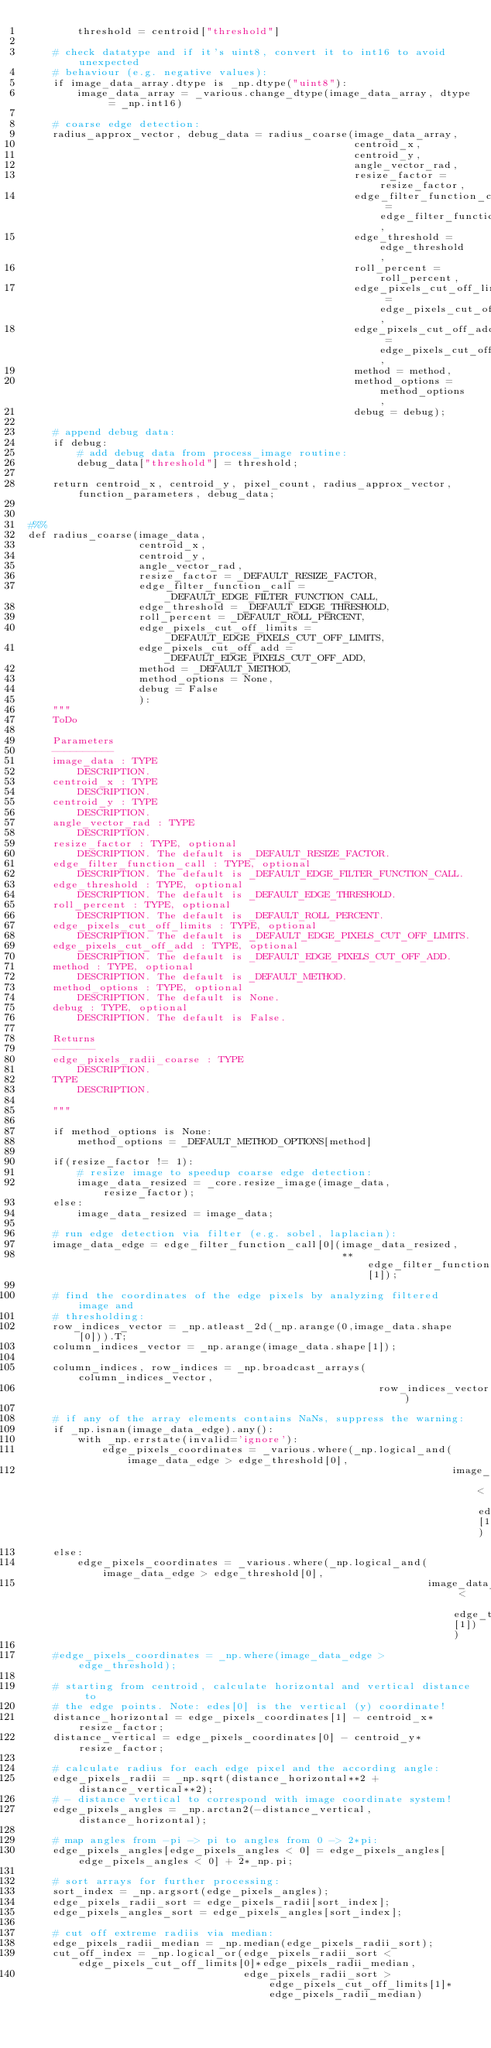<code> <loc_0><loc_0><loc_500><loc_500><_Python_>        threshold = centroid["threshold"]
    
    # check datatype and if it's uint8, convert it to int16 to avoid unexpected
    # behaviour (e.g. negative values):
    if image_data_array.dtype is _np.dtype("uint8"):   
        image_data_array = _various.change_dtype(image_data_array, dtype = _np.int16)
    
    # coarse edge detection:
    radius_approx_vector, debug_data = radius_coarse(image_data_array,
                                                     centroid_x,
                                                     centroid_y, 
                                                     angle_vector_rad,
                                                     resize_factor = resize_factor,
                                                     edge_filter_function_call = edge_filter_function_call,
                                                     edge_threshold = edge_threshold,
                                                     roll_percent = roll_percent,
                                                     edge_pixels_cut_off_limits = edge_pixels_cut_off_limits,
                                                     edge_pixels_cut_off_add = edge_pixels_cut_off_add,
                                                     method = method,
                                                     method_options = method_options,
                                                     debug = debug);
    
    # append debug data:
    if debug:
        # add debug data from process_image routine:
        debug_data["threshold"] = threshold;
    
    return centroid_x, centroid_y, pixel_count, radius_approx_vector, function_parameters, debug_data;


#%%
def radius_coarse(image_data,
                  centroid_x,
                  centroid_y,
                  angle_vector_rad, 
                  resize_factor = _DEFAULT_RESIZE_FACTOR,
                  edge_filter_function_call = _DEFAULT_EDGE_FILTER_FUNCTION_CALL,
                  edge_threshold = _DEFAULT_EDGE_THRESHOLD,
                  roll_percent = _DEFAULT_ROLL_PERCENT,
                  edge_pixels_cut_off_limits = _DEFAULT_EDGE_PIXELS_CUT_OFF_LIMITS,
                  edge_pixels_cut_off_add = _DEFAULT_EDGE_PIXELS_CUT_OFF_ADD,
                  method = _DEFAULT_METHOD,
                  method_options = None,
                  debug = False
                  ):
    """
    ToDo

    Parameters
    ----------
    image_data : TYPE
        DESCRIPTION.
    centroid_x : TYPE
        DESCRIPTION.
    centroid_y : TYPE
        DESCRIPTION.
    angle_vector_rad : TYPE
        DESCRIPTION.
    resize_factor : TYPE, optional
        DESCRIPTION. The default is _DEFAULT_RESIZE_FACTOR.
    edge_filter_function_call : TYPE, optional
        DESCRIPTION. The default is _DEFAULT_EDGE_FILTER_FUNCTION_CALL.
    edge_threshold : TYPE, optional
        DESCRIPTION. The default is _DEFAULT_EDGE_THRESHOLD.
    roll_percent : TYPE, optional
        DESCRIPTION. The default is _DEFAULT_ROLL_PERCENT.
    edge_pixels_cut_off_limits : TYPE, optional
        DESCRIPTION. The default is _DEFAULT_EDGE_PIXELS_CUT_OFF_LIMITS.
    edge_pixels_cut_off_add : TYPE, optional
        DESCRIPTION. The default is _DEFAULT_EDGE_PIXELS_CUT_OFF_ADD.
    method : TYPE, optional
        DESCRIPTION. The default is _DEFAULT_METHOD.
    method_options : TYPE, optional
        DESCRIPTION. The default is None.
    debug : TYPE, optional
        DESCRIPTION. The default is False.

    Returns
    -------
    edge_pixels_radii_coarse : TYPE
        DESCRIPTION.
    TYPE
        DESCRIPTION.

    """
    
    if method_options is None:
        method_options = _DEFAULT_METHOD_OPTIONS[method]
    
    if(resize_factor != 1):
        # resize image to speedup coarse edge detection:
        image_data_resized = _core.resize_image(image_data, resize_factor);
    else:
        image_data_resized = image_data;
    
    # run edge detection via filter (e.g. sobel, laplacian):
    image_data_edge = edge_filter_function_call[0](image_data_resized,
                                                   **edge_filter_function_call[1]);
    
    # find the coordinates of the edge pixels by analyzing filtered image and 
    # thresholding:
    row_indices_vector = _np.atleast_2d(_np.arange(0,image_data.shape[0])).T;
    column_indices_vector = _np.arange(image_data.shape[1]);
    
    column_indices, row_indices = _np.broadcast_arrays(column_indices_vector,
                                                         row_indices_vector)
    
    # if any of the array elements contains NaNs, suppress the warning:
    if _np.isnan(image_data_edge).any():
        with _np.errstate(invalid='ignore'):
            edge_pixels_coordinates = _various.where(_np.logical_and(image_data_edge > edge_threshold[0], 
                                                                     image_data_edge < edge_threshold[1]))
    else:
        edge_pixels_coordinates = _various.where(_np.logical_and(image_data_edge > edge_threshold[0], 
                                                                 image_data_edge < edge_threshold[1]))
                
    #edge_pixels_coordinates = _np.where(image_data_edge > edge_threshold);
    
    # starting from centroid, calculate horizontal and vertical distance to 
    # the edge points. Note: edes[0] is the vertical (y) coordinate!
    distance_horizontal = edge_pixels_coordinates[1] - centroid_x*resize_factor;
    distance_vertical = edge_pixels_coordinates[0] - centroid_y*resize_factor;
    
    # calculate radius for each edge pixel and the according angle:
    edge_pixels_radii = _np.sqrt(distance_horizontal**2 + distance_vertical**2);
    # - distance vertical to correspond with image coordinate system!
    edge_pixels_angles = _np.arctan2(-distance_vertical, distance_horizontal);
    
    # map angles from -pi -> pi to angles from 0 -> 2*pi:
    edge_pixels_angles[edge_pixels_angles < 0] = edge_pixels_angles[edge_pixels_angles < 0] + 2*_np.pi;
    
    # sort arrays for further processing:
    sort_index = _np.argsort(edge_pixels_angles);
    edge_pixels_radii_sort = edge_pixels_radii[sort_index];
    edge_pixels_angles_sort = edge_pixels_angles[sort_index];

    # cut off extreme radiis via median:
    edge_pixels_radii_median = _np.median(edge_pixels_radii_sort);
    cut_off_index = _np.logical_or(edge_pixels_radii_sort < edge_pixels_cut_off_limits[0]*edge_pixels_radii_median,
                                   edge_pixels_radii_sort > edge_pixels_cut_off_limits[1]*edge_pixels_radii_median)</code> 